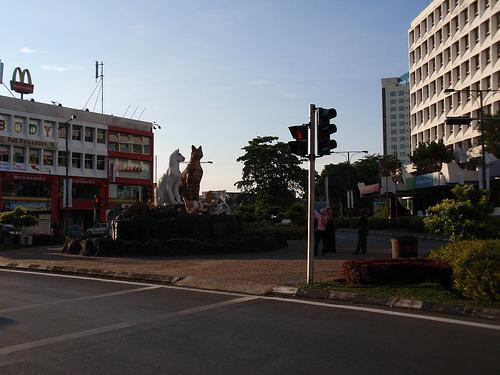How many animal statues are there?
Give a very brief answer. 2. 